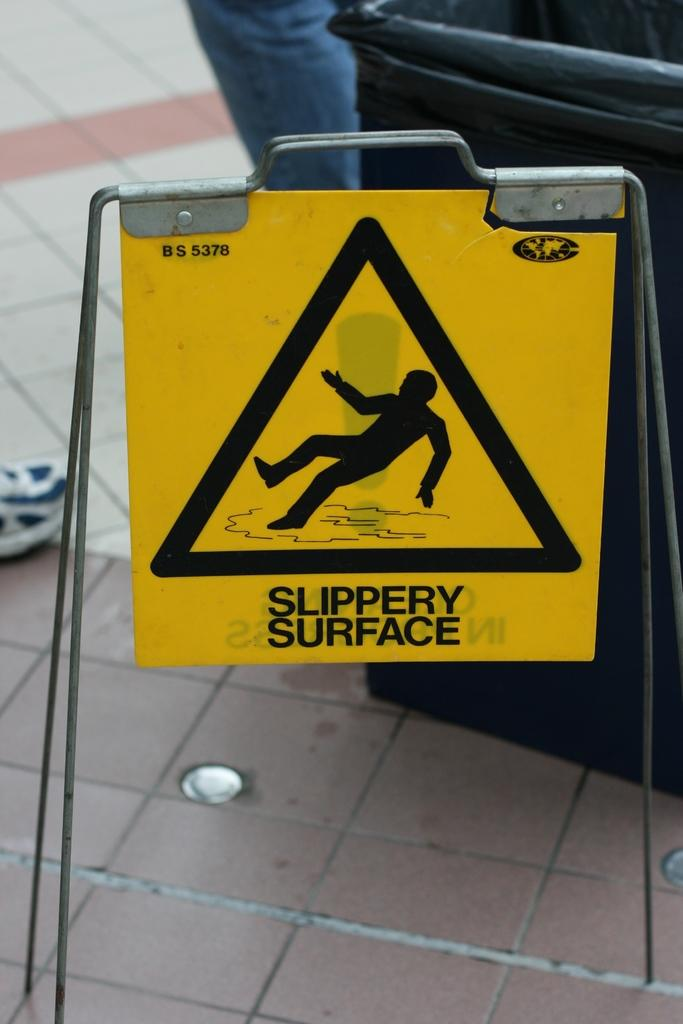What is the main object in the image? There is a caution board in the image. What else can be seen in the background of the image? There is a bin in the background of the image. Can you describe any part of a person in the image? A person's leg is visible in the image. How many goldfish are swimming in the caution board in the image? There are no goldfish present in the image, as it features a caution board and a person's leg. 